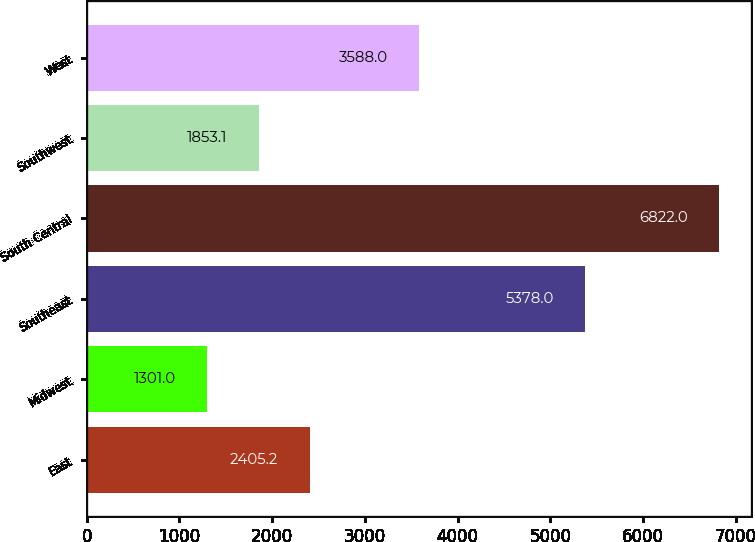Convert chart. <chart><loc_0><loc_0><loc_500><loc_500><bar_chart><fcel>East<fcel>Midwest<fcel>Southeast<fcel>South Central<fcel>Southwest<fcel>West<nl><fcel>2405.2<fcel>1301<fcel>5378<fcel>6822<fcel>1853.1<fcel>3588<nl></chart> 